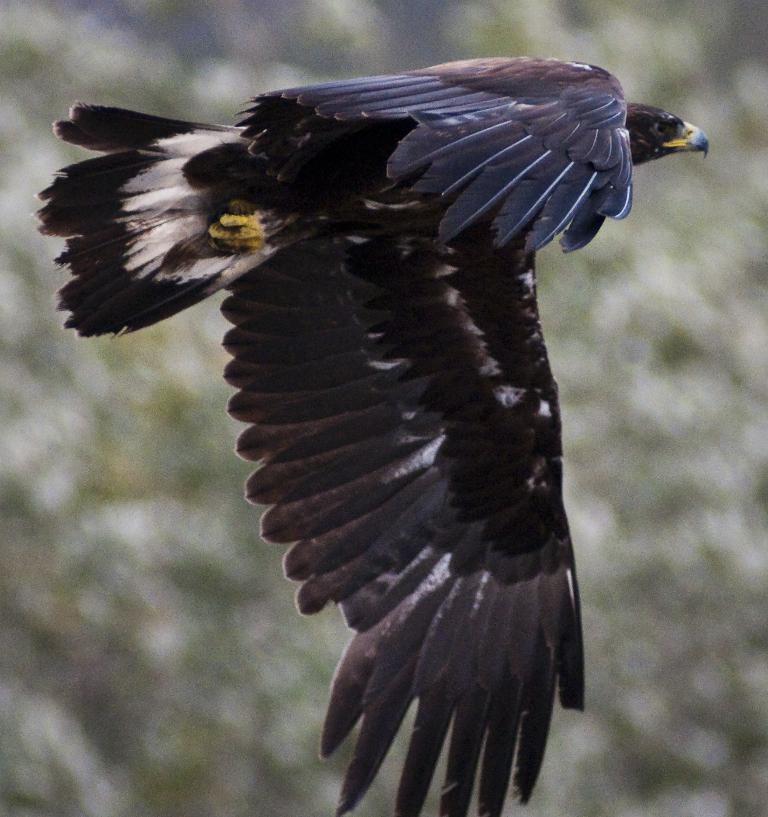How would you summarize this image in a sentence or two? In this image we can see a bird flying in the air and there is a blur background. 